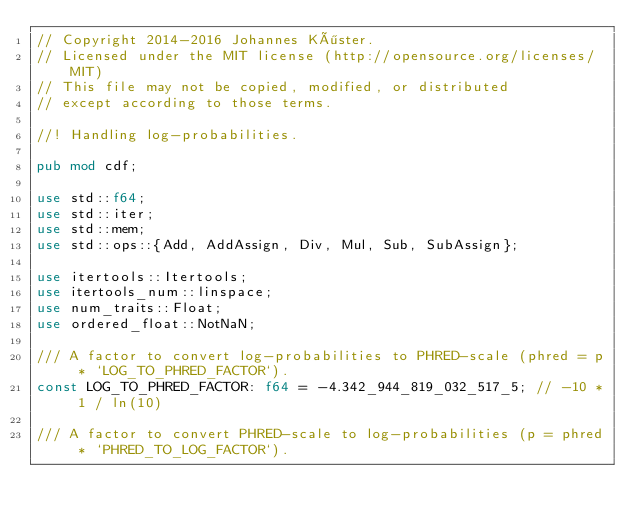Convert code to text. <code><loc_0><loc_0><loc_500><loc_500><_Rust_>// Copyright 2014-2016 Johannes Köster.
// Licensed under the MIT license (http://opensource.org/licenses/MIT)
// This file may not be copied, modified, or distributed
// except according to those terms.

//! Handling log-probabilities.

pub mod cdf;

use std::f64;
use std::iter;
use std::mem;
use std::ops::{Add, AddAssign, Div, Mul, Sub, SubAssign};

use itertools::Itertools;
use itertools_num::linspace;
use num_traits::Float;
use ordered_float::NotNaN;

/// A factor to convert log-probabilities to PHRED-scale (phred = p * `LOG_TO_PHRED_FACTOR`).
const LOG_TO_PHRED_FACTOR: f64 = -4.342_944_819_032_517_5; // -10 * 1 / ln(10)

/// A factor to convert PHRED-scale to log-probabilities (p = phred * `PHRED_TO_LOG_FACTOR`).</code> 